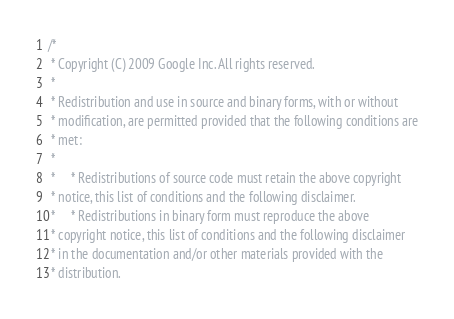Convert code to text. <code><loc_0><loc_0><loc_500><loc_500><_C++_>/*
 * Copyright (C) 2009 Google Inc. All rights reserved.
 *
 * Redistribution and use in source and binary forms, with or without
 * modification, are permitted provided that the following conditions are
 * met:
 *
 *     * Redistributions of source code must retain the above copyright
 * notice, this list of conditions and the following disclaimer.
 *     * Redistributions in binary form must reproduce the above
 * copyright notice, this list of conditions and the following disclaimer
 * in the documentation and/or other materials provided with the
 * distribution.</code> 